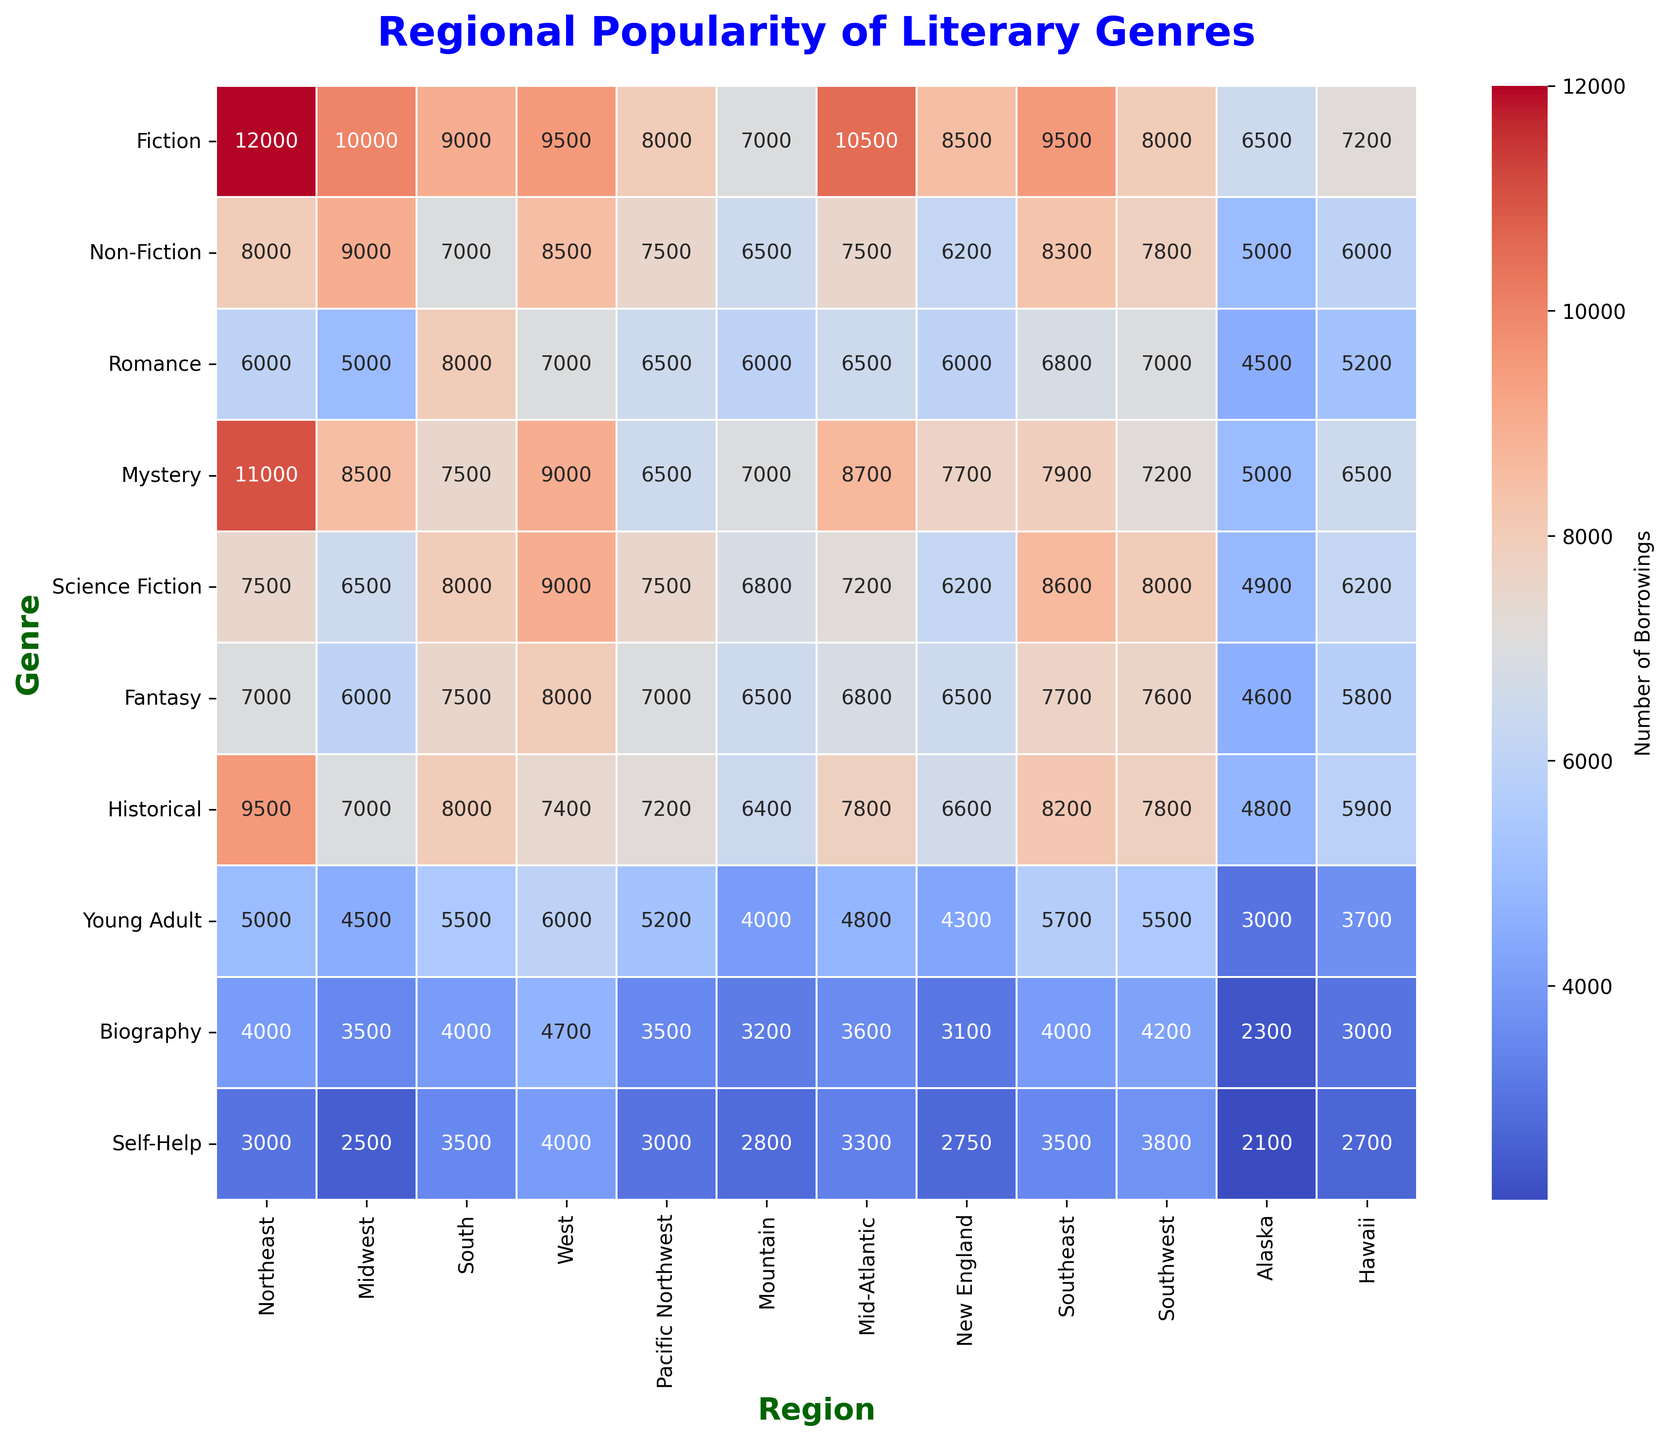Which region has the highest number of borrowings for Fiction? We look at the row for Fiction in the heatmap and see which column has the highest value. The highest value for Fiction is in the Northeast region with 12000 borrowings.
Answer: Northeast What is the total number of borrowings for Mystery across all regions? Sum the Mystery borrowings for each region: 11000 (Northeast) + 8500 (Midwest) + 7500 (South) + 9000 (West) + 6500 (Pacific Northwest) + 7000 (Mountain) + 8700 (Mid-Atlantic) + 7700 (New England) + 7900 (Southeast) + 7200 (Southwest) + 5000 (Alaska) + 6500 (Hawaii) = 94800
Answer: 94800 Which genre has the least borrowings in the Mountain region? Consult the Mountain column and identify the lowest value. The genre with the least borrowings is Biography with 3200 borrowings.
Answer: Biography Are Science Fiction borrowings in the Pacific Northwest greater than in the Midwest? Compare the values from the Science Fiction row for both regions. Pacific Northwest has 7500 borrowings and Midwest has 6500 borrowings, so Pacific Northwest has more.
Answer: Yes What is the difference in the number of Young Adult borrowings between the Southeast and New England regions? Look at the Young Adult values for both Southeast (5700) and New England (4300). Calculate the difference: 5700 - 4300 = 1400
Answer: 1400 How much more popular is Young Adult in Hawaii compared to Alaska based on borrowings? Compare the Young Adult borrowings between Hawaii (3700) and Alaska (3000) and find the difference: 3700 - 3000 = 700
Answer: 700 Which region has the highest number of total borrowings across all genres? Sum the borrowings across all genres for each region and compare. The Northeast region has the highest: 12000+8000+6000+11000+7500+7000+9500+5000+4000+3000 = 82000
Answer: Northeast What is the average number of borrowings for Self-Help across all regions? Find the total of Self-Help borrowings and divide by the number of regions: (3000+2500+3500+4000+3000+2800+3300+2750+3500+3800+2100+2700) / 12 = 32450 / 12 ≈ 2704
Answer: 2704 Which is more popular in the Midwest, Romance or Fantasy? Compare the values for Romance and Fantasy in the Midwest. Romance has 5000 borrowings while Fantasy has 6000. Fantasy is more popular.
Answer: Fantasy What is the combined total of Fiction and Non-Fiction borrowings in the Southwest region? Add the borrowings for Fiction (8000) and Non-Fiction (7800) in the Southwest: 8000 + 7800 = 15800
Answer: 15800 